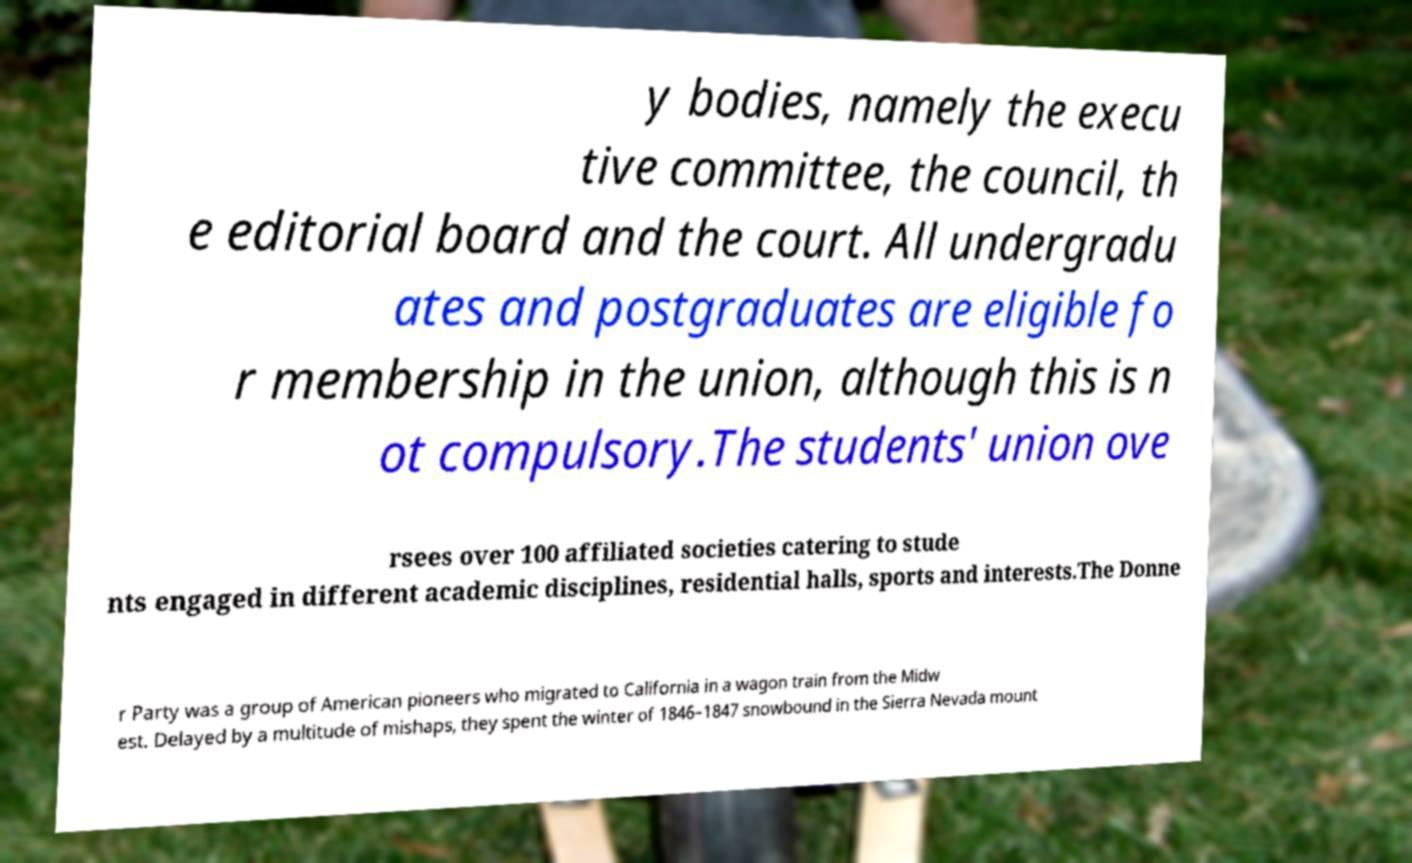Please identify and transcribe the text found in this image. y bodies, namely the execu tive committee, the council, th e editorial board and the court. All undergradu ates and postgraduates are eligible fo r membership in the union, although this is n ot compulsory.The students' union ove rsees over 100 affiliated societies catering to stude nts engaged in different academic disciplines, residential halls, sports and interests.The Donne r Party was a group of American pioneers who migrated to California in a wagon train from the Midw est. Delayed by a multitude of mishaps, they spent the winter of 1846–1847 snowbound in the Sierra Nevada mount 